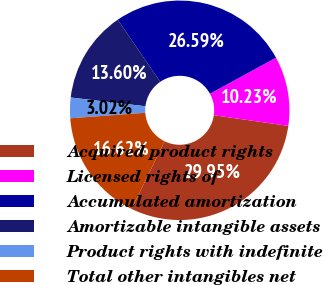Convert chart. <chart><loc_0><loc_0><loc_500><loc_500><pie_chart><fcel>Acquired product rights<fcel>Licensed rights of<fcel>Accumulated amortization<fcel>Amortizable intangible assets<fcel>Product rights with indefinite<fcel>Total other intangibles net<nl><fcel>29.95%<fcel>10.23%<fcel>26.59%<fcel>13.6%<fcel>3.02%<fcel>16.62%<nl></chart> 